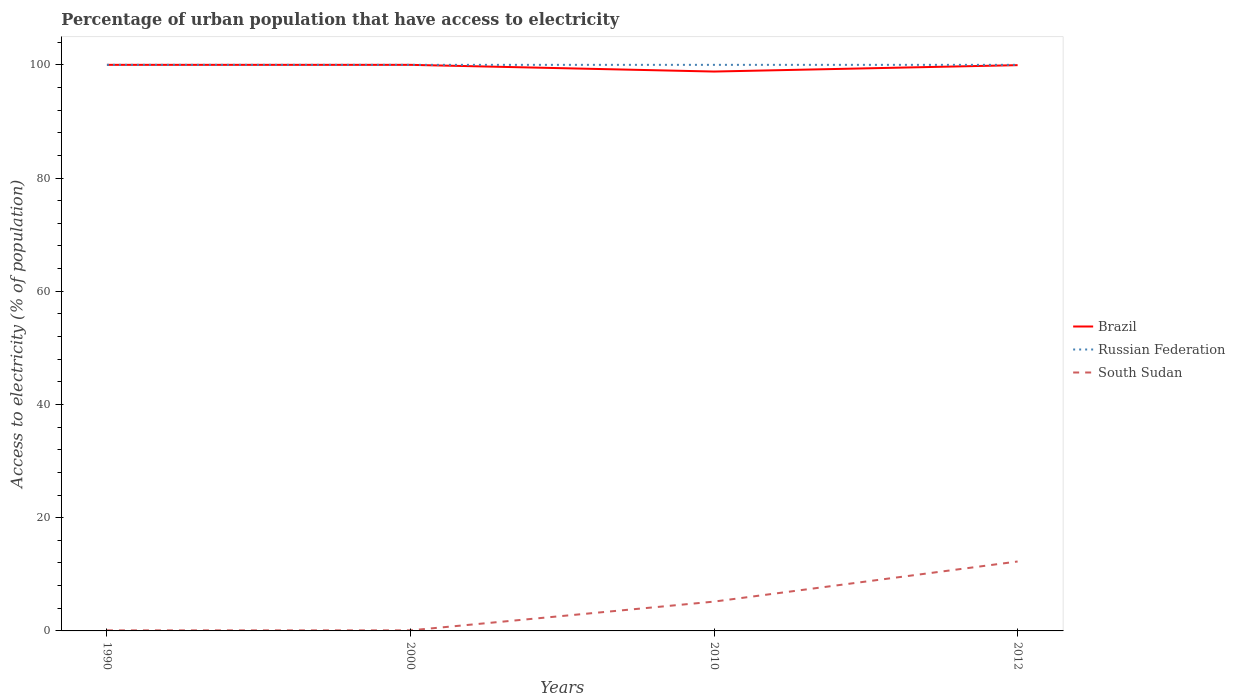Does the line corresponding to Russian Federation intersect with the line corresponding to South Sudan?
Provide a succinct answer. No. Is the number of lines equal to the number of legend labels?
Your response must be concise. Yes. Across all years, what is the maximum percentage of urban population that have access to electricity in Russian Federation?
Your response must be concise. 100. What is the total percentage of urban population that have access to electricity in Russian Federation in the graph?
Keep it short and to the point. 0. What is the difference between the highest and the second highest percentage of urban population that have access to electricity in South Sudan?
Provide a succinct answer. 12.17. Is the percentage of urban population that have access to electricity in South Sudan strictly greater than the percentage of urban population that have access to electricity in Brazil over the years?
Offer a terse response. Yes. How many lines are there?
Your response must be concise. 3. How many years are there in the graph?
Provide a succinct answer. 4. What is the difference between two consecutive major ticks on the Y-axis?
Provide a succinct answer. 20. Does the graph contain any zero values?
Offer a very short reply. No. Does the graph contain grids?
Provide a succinct answer. No. How many legend labels are there?
Your response must be concise. 3. What is the title of the graph?
Give a very brief answer. Percentage of urban population that have access to electricity. What is the label or title of the X-axis?
Your response must be concise. Years. What is the label or title of the Y-axis?
Your response must be concise. Access to electricity (% of population). What is the Access to electricity (% of population) in Brazil in 1990?
Provide a short and direct response. 100. What is the Access to electricity (% of population) in Russian Federation in 1990?
Keep it short and to the point. 100. What is the Access to electricity (% of population) in South Sudan in 1990?
Provide a short and direct response. 0.1. What is the Access to electricity (% of population) of Brazil in 2000?
Offer a very short reply. 100. What is the Access to electricity (% of population) of Russian Federation in 2000?
Offer a terse response. 100. What is the Access to electricity (% of population) of South Sudan in 2000?
Your response must be concise. 0.1. What is the Access to electricity (% of population) of Brazil in 2010?
Give a very brief answer. 98.82. What is the Access to electricity (% of population) in South Sudan in 2010?
Your response must be concise. 5.18. What is the Access to electricity (% of population) in Brazil in 2012?
Provide a succinct answer. 99.95. What is the Access to electricity (% of population) of Russian Federation in 2012?
Give a very brief answer. 100. What is the Access to electricity (% of population) of South Sudan in 2012?
Your answer should be compact. 12.27. Across all years, what is the maximum Access to electricity (% of population) of Brazil?
Offer a very short reply. 100. Across all years, what is the maximum Access to electricity (% of population) of South Sudan?
Keep it short and to the point. 12.27. Across all years, what is the minimum Access to electricity (% of population) in Brazil?
Offer a very short reply. 98.82. Across all years, what is the minimum Access to electricity (% of population) of South Sudan?
Your response must be concise. 0.1. What is the total Access to electricity (% of population) in Brazil in the graph?
Your answer should be compact. 398.76. What is the total Access to electricity (% of population) of South Sudan in the graph?
Offer a very short reply. 17.64. What is the difference between the Access to electricity (% of population) in Russian Federation in 1990 and that in 2000?
Provide a short and direct response. 0. What is the difference between the Access to electricity (% of population) of South Sudan in 1990 and that in 2000?
Keep it short and to the point. 0. What is the difference between the Access to electricity (% of population) of Brazil in 1990 and that in 2010?
Provide a short and direct response. 1.18. What is the difference between the Access to electricity (% of population) of Russian Federation in 1990 and that in 2010?
Your answer should be very brief. 0. What is the difference between the Access to electricity (% of population) in South Sudan in 1990 and that in 2010?
Your response must be concise. -5.08. What is the difference between the Access to electricity (% of population) of Brazil in 1990 and that in 2012?
Offer a very short reply. 0.05. What is the difference between the Access to electricity (% of population) of South Sudan in 1990 and that in 2012?
Offer a terse response. -12.17. What is the difference between the Access to electricity (% of population) in Brazil in 2000 and that in 2010?
Make the answer very short. 1.18. What is the difference between the Access to electricity (% of population) of Russian Federation in 2000 and that in 2010?
Offer a terse response. 0. What is the difference between the Access to electricity (% of population) in South Sudan in 2000 and that in 2010?
Your response must be concise. -5.08. What is the difference between the Access to electricity (% of population) in Brazil in 2000 and that in 2012?
Your response must be concise. 0.05. What is the difference between the Access to electricity (% of population) in Russian Federation in 2000 and that in 2012?
Provide a succinct answer. 0. What is the difference between the Access to electricity (% of population) in South Sudan in 2000 and that in 2012?
Offer a terse response. -12.17. What is the difference between the Access to electricity (% of population) of Brazil in 2010 and that in 2012?
Give a very brief answer. -1.13. What is the difference between the Access to electricity (% of population) in Russian Federation in 2010 and that in 2012?
Keep it short and to the point. 0. What is the difference between the Access to electricity (% of population) of South Sudan in 2010 and that in 2012?
Provide a short and direct response. -7.09. What is the difference between the Access to electricity (% of population) in Brazil in 1990 and the Access to electricity (% of population) in South Sudan in 2000?
Your response must be concise. 99.9. What is the difference between the Access to electricity (% of population) of Russian Federation in 1990 and the Access to electricity (% of population) of South Sudan in 2000?
Offer a terse response. 99.9. What is the difference between the Access to electricity (% of population) in Brazil in 1990 and the Access to electricity (% of population) in South Sudan in 2010?
Provide a short and direct response. 94.82. What is the difference between the Access to electricity (% of population) of Russian Federation in 1990 and the Access to electricity (% of population) of South Sudan in 2010?
Offer a very short reply. 94.82. What is the difference between the Access to electricity (% of population) in Brazil in 1990 and the Access to electricity (% of population) in South Sudan in 2012?
Make the answer very short. 87.73. What is the difference between the Access to electricity (% of population) of Russian Federation in 1990 and the Access to electricity (% of population) of South Sudan in 2012?
Keep it short and to the point. 87.73. What is the difference between the Access to electricity (% of population) in Brazil in 2000 and the Access to electricity (% of population) in South Sudan in 2010?
Your answer should be very brief. 94.82. What is the difference between the Access to electricity (% of population) in Russian Federation in 2000 and the Access to electricity (% of population) in South Sudan in 2010?
Give a very brief answer. 94.82. What is the difference between the Access to electricity (% of population) in Brazil in 2000 and the Access to electricity (% of population) in Russian Federation in 2012?
Make the answer very short. 0. What is the difference between the Access to electricity (% of population) in Brazil in 2000 and the Access to electricity (% of population) in South Sudan in 2012?
Provide a short and direct response. 87.73. What is the difference between the Access to electricity (% of population) in Russian Federation in 2000 and the Access to electricity (% of population) in South Sudan in 2012?
Your answer should be compact. 87.73. What is the difference between the Access to electricity (% of population) in Brazil in 2010 and the Access to electricity (% of population) in Russian Federation in 2012?
Your response must be concise. -1.18. What is the difference between the Access to electricity (% of population) in Brazil in 2010 and the Access to electricity (% of population) in South Sudan in 2012?
Provide a succinct answer. 86.55. What is the difference between the Access to electricity (% of population) in Russian Federation in 2010 and the Access to electricity (% of population) in South Sudan in 2012?
Give a very brief answer. 87.73. What is the average Access to electricity (% of population) of Brazil per year?
Provide a succinct answer. 99.69. What is the average Access to electricity (% of population) in South Sudan per year?
Ensure brevity in your answer.  4.41. In the year 1990, what is the difference between the Access to electricity (% of population) of Brazil and Access to electricity (% of population) of Russian Federation?
Make the answer very short. 0. In the year 1990, what is the difference between the Access to electricity (% of population) of Brazil and Access to electricity (% of population) of South Sudan?
Offer a terse response. 99.9. In the year 1990, what is the difference between the Access to electricity (% of population) of Russian Federation and Access to electricity (% of population) of South Sudan?
Offer a terse response. 99.9. In the year 2000, what is the difference between the Access to electricity (% of population) in Brazil and Access to electricity (% of population) in South Sudan?
Provide a short and direct response. 99.9. In the year 2000, what is the difference between the Access to electricity (% of population) of Russian Federation and Access to electricity (% of population) of South Sudan?
Offer a very short reply. 99.9. In the year 2010, what is the difference between the Access to electricity (% of population) of Brazil and Access to electricity (% of population) of Russian Federation?
Your answer should be very brief. -1.18. In the year 2010, what is the difference between the Access to electricity (% of population) in Brazil and Access to electricity (% of population) in South Sudan?
Your answer should be very brief. 93.64. In the year 2010, what is the difference between the Access to electricity (% of population) in Russian Federation and Access to electricity (% of population) in South Sudan?
Offer a very short reply. 94.82. In the year 2012, what is the difference between the Access to electricity (% of population) of Brazil and Access to electricity (% of population) of Russian Federation?
Keep it short and to the point. -0.05. In the year 2012, what is the difference between the Access to electricity (% of population) in Brazil and Access to electricity (% of population) in South Sudan?
Provide a short and direct response. 87.68. In the year 2012, what is the difference between the Access to electricity (% of population) of Russian Federation and Access to electricity (% of population) of South Sudan?
Keep it short and to the point. 87.73. What is the ratio of the Access to electricity (% of population) of Russian Federation in 1990 to that in 2010?
Provide a succinct answer. 1. What is the ratio of the Access to electricity (% of population) of South Sudan in 1990 to that in 2010?
Give a very brief answer. 0.02. What is the ratio of the Access to electricity (% of population) of South Sudan in 1990 to that in 2012?
Ensure brevity in your answer.  0.01. What is the ratio of the Access to electricity (% of population) in Brazil in 2000 to that in 2010?
Provide a succinct answer. 1.01. What is the ratio of the Access to electricity (% of population) of Russian Federation in 2000 to that in 2010?
Your response must be concise. 1. What is the ratio of the Access to electricity (% of population) of South Sudan in 2000 to that in 2010?
Provide a succinct answer. 0.02. What is the ratio of the Access to electricity (% of population) of Brazil in 2000 to that in 2012?
Offer a terse response. 1. What is the ratio of the Access to electricity (% of population) of South Sudan in 2000 to that in 2012?
Offer a terse response. 0.01. What is the ratio of the Access to electricity (% of population) of Brazil in 2010 to that in 2012?
Keep it short and to the point. 0.99. What is the ratio of the Access to electricity (% of population) of South Sudan in 2010 to that in 2012?
Offer a very short reply. 0.42. What is the difference between the highest and the second highest Access to electricity (% of population) in Brazil?
Your answer should be compact. 0. What is the difference between the highest and the second highest Access to electricity (% of population) in Russian Federation?
Ensure brevity in your answer.  0. What is the difference between the highest and the second highest Access to electricity (% of population) of South Sudan?
Your response must be concise. 7.09. What is the difference between the highest and the lowest Access to electricity (% of population) of Brazil?
Ensure brevity in your answer.  1.18. What is the difference between the highest and the lowest Access to electricity (% of population) in Russian Federation?
Keep it short and to the point. 0. What is the difference between the highest and the lowest Access to electricity (% of population) in South Sudan?
Give a very brief answer. 12.17. 